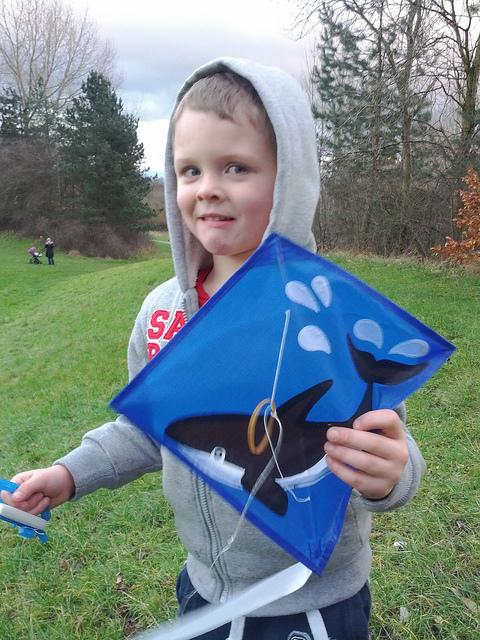What animal is on the kite? Please explain your reasoning. whale. The whale is on the kite. 